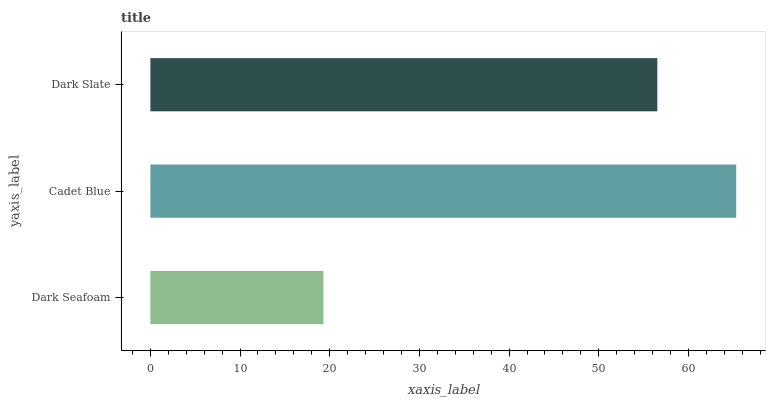Is Dark Seafoam the minimum?
Answer yes or no. Yes. Is Cadet Blue the maximum?
Answer yes or no. Yes. Is Dark Slate the minimum?
Answer yes or no. No. Is Dark Slate the maximum?
Answer yes or no. No. Is Cadet Blue greater than Dark Slate?
Answer yes or no. Yes. Is Dark Slate less than Cadet Blue?
Answer yes or no. Yes. Is Dark Slate greater than Cadet Blue?
Answer yes or no. No. Is Cadet Blue less than Dark Slate?
Answer yes or no. No. Is Dark Slate the high median?
Answer yes or no. Yes. Is Dark Slate the low median?
Answer yes or no. Yes. Is Cadet Blue the high median?
Answer yes or no. No. Is Cadet Blue the low median?
Answer yes or no. No. 